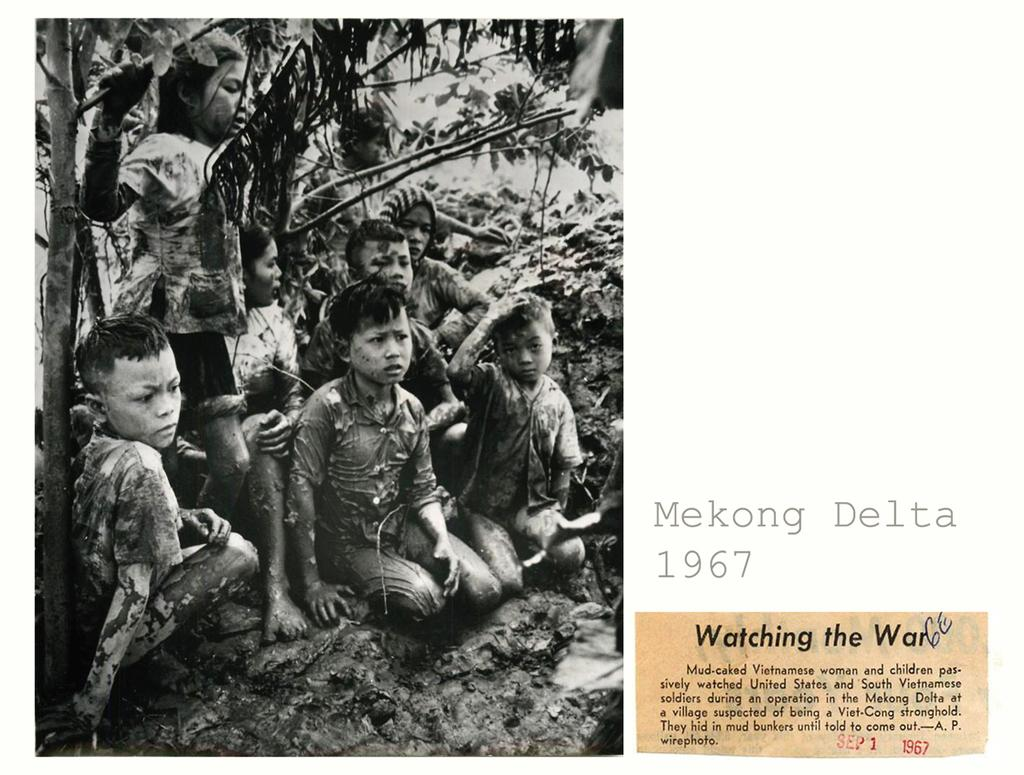Who or what is present in the image? There are children in the image. Where are the children located? The children are on the sand. Is there any text visible in the image? Yes, there is some text visible in the image. What type of crook can be seen in the image? There is no crook present in the image. What is the name of the person the children are paying attention to in the image? The provided facts do not mention any specific person or name, so it cannot be determined from the image. 